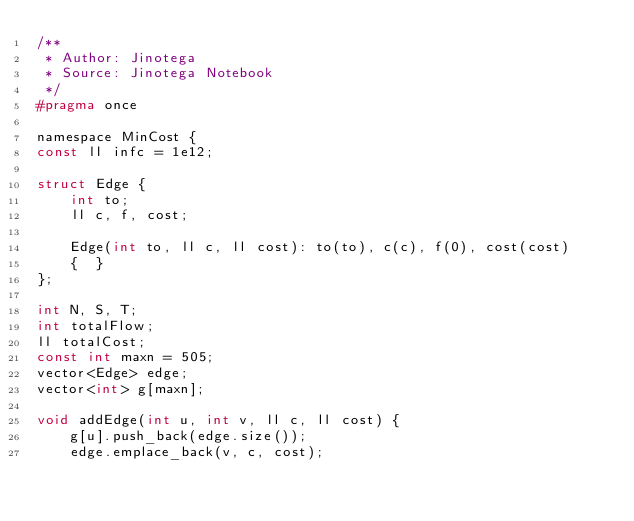Convert code to text. <code><loc_0><loc_0><loc_500><loc_500><_C_>/**
 * Author: Jinotega
 * Source: Jinotega Notebook
 */
#pragma once

namespace MinCost {
const ll infc = 1e12;

struct Edge {
    int to;
    ll c, f, cost;

    Edge(int to, ll c, ll cost): to(to), c(c), f(0), cost(cost)
    {  }
};

int N, S, T;
int totalFlow;
ll totalCost;
const int maxn = 505;
vector<Edge> edge;
vector<int> g[maxn];

void addEdge(int u, int v, ll c, ll cost) {
    g[u].push_back(edge.size());
    edge.emplace_back(v, c, cost);</code> 